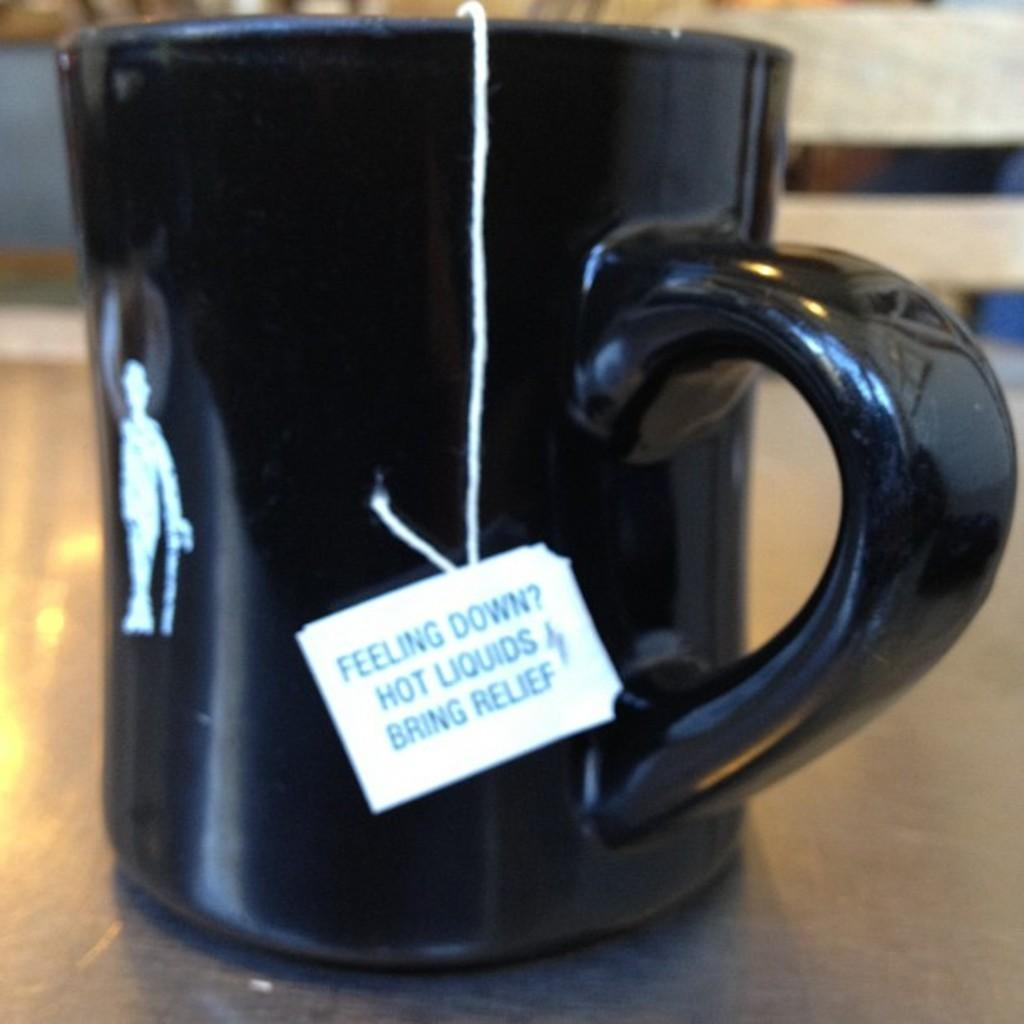<image>
Give a short and clear explanation of the subsequent image. a mug with a tea bag tag saying feeling down? hot liquids bring relief 